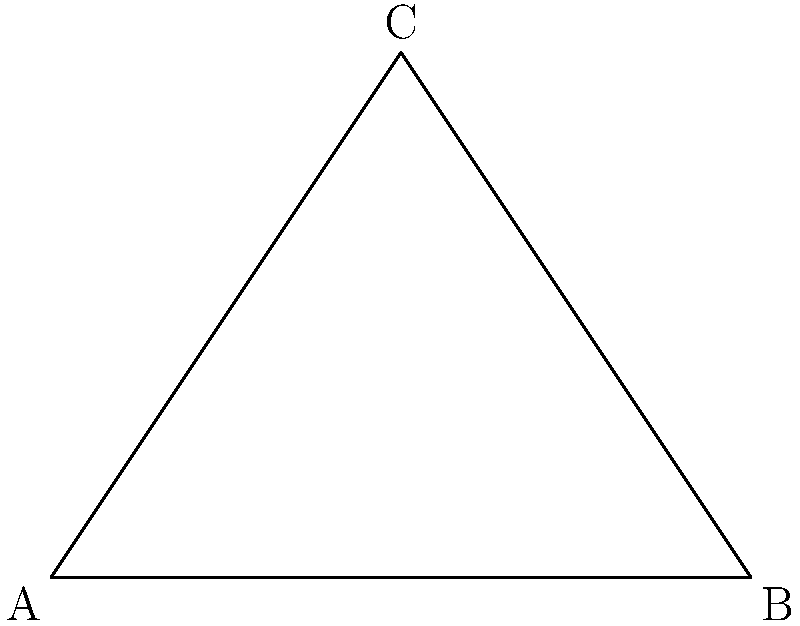In a triangle ABC, two interior angles are given: $\angle A = 55°$ and $\angle B = 70°$. Calculate the exterior angle at vertex C, denoted as $x°$ in the figure. To solve this problem, let's follow these steps:

1) First, recall that the sum of interior angles in a triangle is always 180°.

2) We can find the third interior angle (at C) by subtracting the known angles from 180°:
   $\angle C = 180° - (55° + 70°) = 180° - 125° = 55°$

3) Now, remember that an exterior angle of a triangle is supplementary to the interior angle at the same vertex. This means they add up to 180°.

4) Therefore, we can find the exterior angle $x°$ by subtracting the interior angle at C from 180°:
   $x° = 180° - \angle C = 180° - 55° = 125°$

This approach not only solves the problem but also reinforces important geometric concepts about triangles and angles, which can be particularly helpful for students with Asperger's Syndrome who may benefit from clear, logical steps and connections between different mathematical ideas.
Answer: $125°$ 